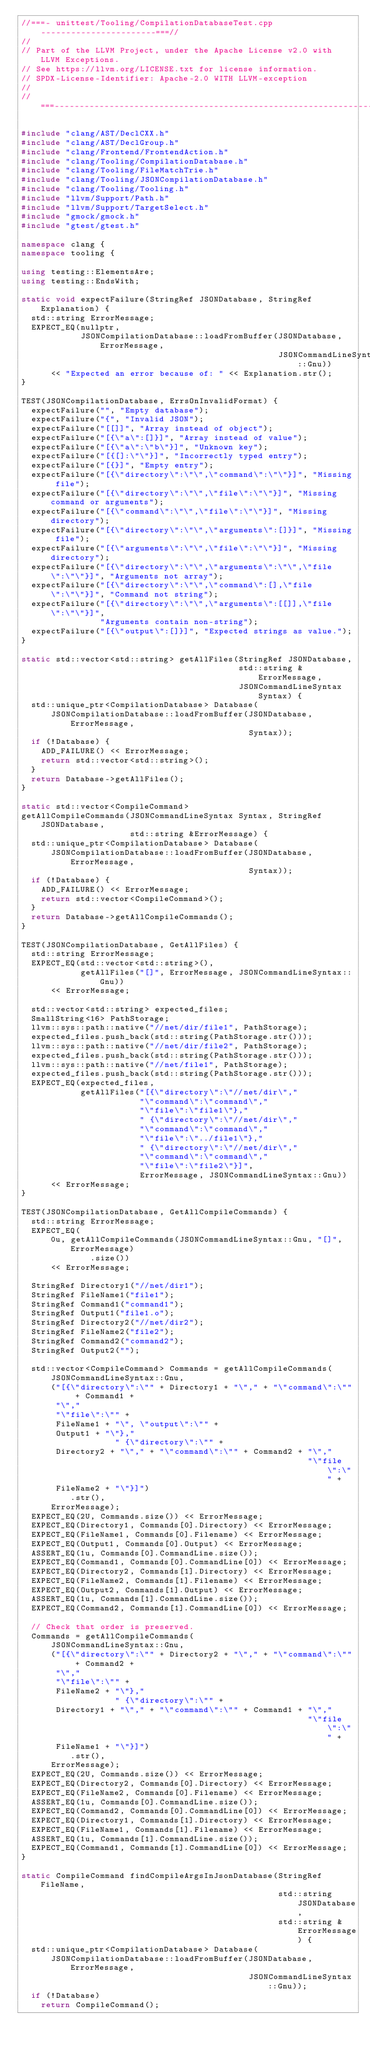Convert code to text. <code><loc_0><loc_0><loc_500><loc_500><_C++_>//===- unittest/Tooling/CompilationDatabaseTest.cpp -----------------------===//
//
// Part of the LLVM Project, under the Apache License v2.0 with LLVM Exceptions.
// See https://llvm.org/LICENSE.txt for license information.
// SPDX-License-Identifier: Apache-2.0 WITH LLVM-exception
//
//===----------------------------------------------------------------------===//

#include "clang/AST/DeclCXX.h"
#include "clang/AST/DeclGroup.h"
#include "clang/Frontend/FrontendAction.h"
#include "clang/Tooling/CompilationDatabase.h"
#include "clang/Tooling/FileMatchTrie.h"
#include "clang/Tooling/JSONCompilationDatabase.h"
#include "clang/Tooling/Tooling.h"
#include "llvm/Support/Path.h"
#include "llvm/Support/TargetSelect.h"
#include "gmock/gmock.h"
#include "gtest/gtest.h"

namespace clang {
namespace tooling {

using testing::ElementsAre;
using testing::EndsWith;

static void expectFailure(StringRef JSONDatabase, StringRef Explanation) {
  std::string ErrorMessage;
  EXPECT_EQ(nullptr,
            JSONCompilationDatabase::loadFromBuffer(JSONDatabase, ErrorMessage,
                                                    JSONCommandLineSyntax::Gnu))
      << "Expected an error because of: " << Explanation.str();
}

TEST(JSONCompilationDatabase, ErrsOnInvalidFormat) {
  expectFailure("", "Empty database");
  expectFailure("{", "Invalid JSON");
  expectFailure("[[]]", "Array instead of object");
  expectFailure("[{\"a\":[]}]", "Array instead of value");
  expectFailure("[{\"a\":\"b\"}]", "Unknown key");
  expectFailure("[{[]:\"\"}]", "Incorrectly typed entry");
  expectFailure("[{}]", "Empty entry");
  expectFailure("[{\"directory\":\"\",\"command\":\"\"}]", "Missing file");
  expectFailure("[{\"directory\":\"\",\"file\":\"\"}]", "Missing command or arguments");
  expectFailure("[{\"command\":\"\",\"file\":\"\"}]", "Missing directory");
  expectFailure("[{\"directory\":\"\",\"arguments\":[]}]", "Missing file");
  expectFailure("[{\"arguments\":\"\",\"file\":\"\"}]", "Missing directory");
  expectFailure("[{\"directory\":\"\",\"arguments\":\"\",\"file\":\"\"}]", "Arguments not array");
  expectFailure("[{\"directory\":\"\",\"command\":[],\"file\":\"\"}]", "Command not string");
  expectFailure("[{\"directory\":\"\",\"arguments\":[[]],\"file\":\"\"}]",
                "Arguments contain non-string");
  expectFailure("[{\"output\":[]}]", "Expected strings as value.");
}

static std::vector<std::string> getAllFiles(StringRef JSONDatabase,
                                            std::string &ErrorMessage,
                                            JSONCommandLineSyntax Syntax) {
  std::unique_ptr<CompilationDatabase> Database(
      JSONCompilationDatabase::loadFromBuffer(JSONDatabase, ErrorMessage,
                                              Syntax));
  if (!Database) {
    ADD_FAILURE() << ErrorMessage;
    return std::vector<std::string>();
  }
  return Database->getAllFiles();
}

static std::vector<CompileCommand>
getAllCompileCommands(JSONCommandLineSyntax Syntax, StringRef JSONDatabase,
                      std::string &ErrorMessage) {
  std::unique_ptr<CompilationDatabase> Database(
      JSONCompilationDatabase::loadFromBuffer(JSONDatabase, ErrorMessage,
                                              Syntax));
  if (!Database) {
    ADD_FAILURE() << ErrorMessage;
    return std::vector<CompileCommand>();
  }
  return Database->getAllCompileCommands();
}

TEST(JSONCompilationDatabase, GetAllFiles) {
  std::string ErrorMessage;
  EXPECT_EQ(std::vector<std::string>(),
            getAllFiles("[]", ErrorMessage, JSONCommandLineSyntax::Gnu))
      << ErrorMessage;

  std::vector<std::string> expected_files;
  SmallString<16> PathStorage;
  llvm::sys::path::native("//net/dir/file1", PathStorage);
  expected_files.push_back(std::string(PathStorage.str()));
  llvm::sys::path::native("//net/dir/file2", PathStorage);
  expected_files.push_back(std::string(PathStorage.str()));
  llvm::sys::path::native("//net/file1", PathStorage);
  expected_files.push_back(std::string(PathStorage.str()));
  EXPECT_EQ(expected_files,
            getAllFiles("[{\"directory\":\"//net/dir\","
                        "\"command\":\"command\","
                        "\"file\":\"file1\"},"
                        " {\"directory\":\"//net/dir\","
                        "\"command\":\"command\","
                        "\"file\":\"../file1\"},"
                        " {\"directory\":\"//net/dir\","
                        "\"command\":\"command\","
                        "\"file\":\"file2\"}]",
                        ErrorMessage, JSONCommandLineSyntax::Gnu))
      << ErrorMessage;
}

TEST(JSONCompilationDatabase, GetAllCompileCommands) {
  std::string ErrorMessage;
  EXPECT_EQ(
      0u, getAllCompileCommands(JSONCommandLineSyntax::Gnu, "[]", ErrorMessage)
              .size())
      << ErrorMessage;

  StringRef Directory1("//net/dir1");
  StringRef FileName1("file1");
  StringRef Command1("command1");
  StringRef Output1("file1.o");
  StringRef Directory2("//net/dir2");
  StringRef FileName2("file2");
  StringRef Command2("command2");
  StringRef Output2("");

  std::vector<CompileCommand> Commands = getAllCompileCommands(
      JSONCommandLineSyntax::Gnu,
      ("[{\"directory\":\"" + Directory1 + "\"," + "\"command\":\"" + Command1 +
       "\","
       "\"file\":\"" +
       FileName1 + "\", \"output\":\"" +
       Output1 + "\"},"
                   " {\"directory\":\"" +
       Directory2 + "\"," + "\"command\":\"" + Command2 + "\","
                                                          "\"file\":\"" +
       FileName2 + "\"}]")
          .str(),
      ErrorMessage);
  EXPECT_EQ(2U, Commands.size()) << ErrorMessage;
  EXPECT_EQ(Directory1, Commands[0].Directory) << ErrorMessage;
  EXPECT_EQ(FileName1, Commands[0].Filename) << ErrorMessage;
  EXPECT_EQ(Output1, Commands[0].Output) << ErrorMessage;
  ASSERT_EQ(1u, Commands[0].CommandLine.size());
  EXPECT_EQ(Command1, Commands[0].CommandLine[0]) << ErrorMessage;
  EXPECT_EQ(Directory2, Commands[1].Directory) << ErrorMessage;
  EXPECT_EQ(FileName2, Commands[1].Filename) << ErrorMessage;
  EXPECT_EQ(Output2, Commands[1].Output) << ErrorMessage;
  ASSERT_EQ(1u, Commands[1].CommandLine.size());
  EXPECT_EQ(Command2, Commands[1].CommandLine[0]) << ErrorMessage;

  // Check that order is preserved.
  Commands = getAllCompileCommands(
      JSONCommandLineSyntax::Gnu,
      ("[{\"directory\":\"" + Directory2 + "\"," + "\"command\":\"" + Command2 +
       "\","
       "\"file\":\"" +
       FileName2 + "\"},"
                   " {\"directory\":\"" +
       Directory1 + "\"," + "\"command\":\"" + Command1 + "\","
                                                          "\"file\":\"" +
       FileName1 + "\"}]")
          .str(),
      ErrorMessage);
  EXPECT_EQ(2U, Commands.size()) << ErrorMessage;
  EXPECT_EQ(Directory2, Commands[0].Directory) << ErrorMessage;
  EXPECT_EQ(FileName2, Commands[0].Filename) << ErrorMessage;
  ASSERT_EQ(1u, Commands[0].CommandLine.size());
  EXPECT_EQ(Command2, Commands[0].CommandLine[0]) << ErrorMessage;
  EXPECT_EQ(Directory1, Commands[1].Directory) << ErrorMessage;
  EXPECT_EQ(FileName1, Commands[1].Filename) << ErrorMessage;
  ASSERT_EQ(1u, Commands[1].CommandLine.size());
  EXPECT_EQ(Command1, Commands[1].CommandLine[0]) << ErrorMessage;
}

static CompileCommand findCompileArgsInJsonDatabase(StringRef FileName,
                                                    std::string JSONDatabase,
                                                    std::string &ErrorMessage) {
  std::unique_ptr<CompilationDatabase> Database(
      JSONCompilationDatabase::loadFromBuffer(JSONDatabase, ErrorMessage,
                                              JSONCommandLineSyntax::Gnu));
  if (!Database)
    return CompileCommand();</code> 